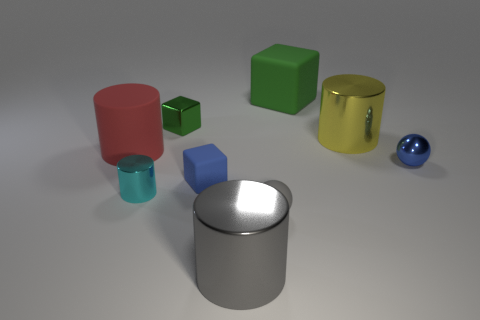What number of other objects are the same color as the matte sphere?
Your response must be concise. 1. How many cylinders are either red matte things or blue objects?
Offer a terse response. 1. What is the color of the big metallic thing that is to the right of the big thing that is behind the yellow cylinder?
Offer a terse response. Yellow. What is the shape of the large yellow thing?
Offer a terse response. Cylinder. There is a thing that is right of the yellow thing; does it have the same size as the tiny cyan cylinder?
Make the answer very short. Yes. Are there any yellow objects that have the same material as the small gray ball?
Offer a very short reply. No. What number of things are objects that are in front of the tiny blue metallic thing or tiny cyan metal spheres?
Offer a very short reply. 4. Are any tiny cyan objects visible?
Provide a short and direct response. Yes. What is the shape of the object that is behind the red thing and in front of the green shiny block?
Offer a terse response. Cylinder. There is a ball that is behind the cyan cylinder; what is its size?
Offer a terse response. Small. 